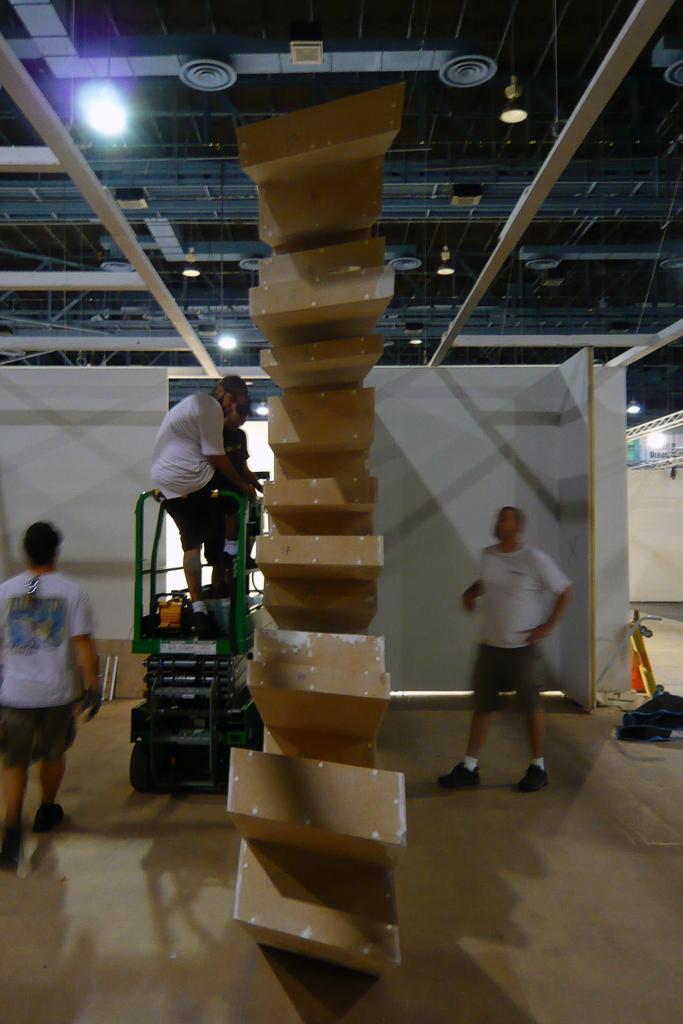Can you describe this image briefly? In the picture we can see inside the shed with a light to the ceiling and a pillar which is shaped as a boxes and beside it we can see a man standing on the machine and beside him we can see another person standing and on the other side of the pillar we can see another man they are with white T-shirts. 